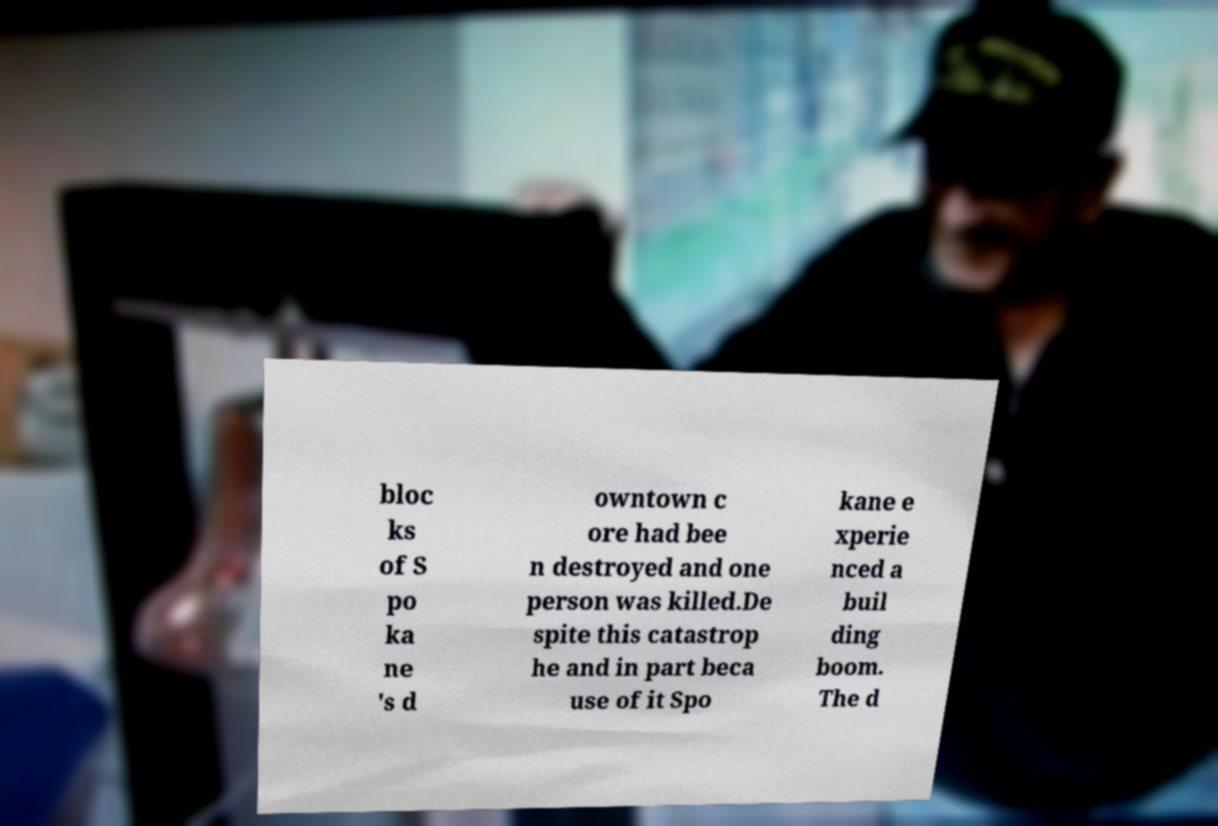Could you assist in decoding the text presented in this image and type it out clearly? bloc ks of S po ka ne 's d owntown c ore had bee n destroyed and one person was killed.De spite this catastrop he and in part beca use of it Spo kane e xperie nced a buil ding boom. The d 